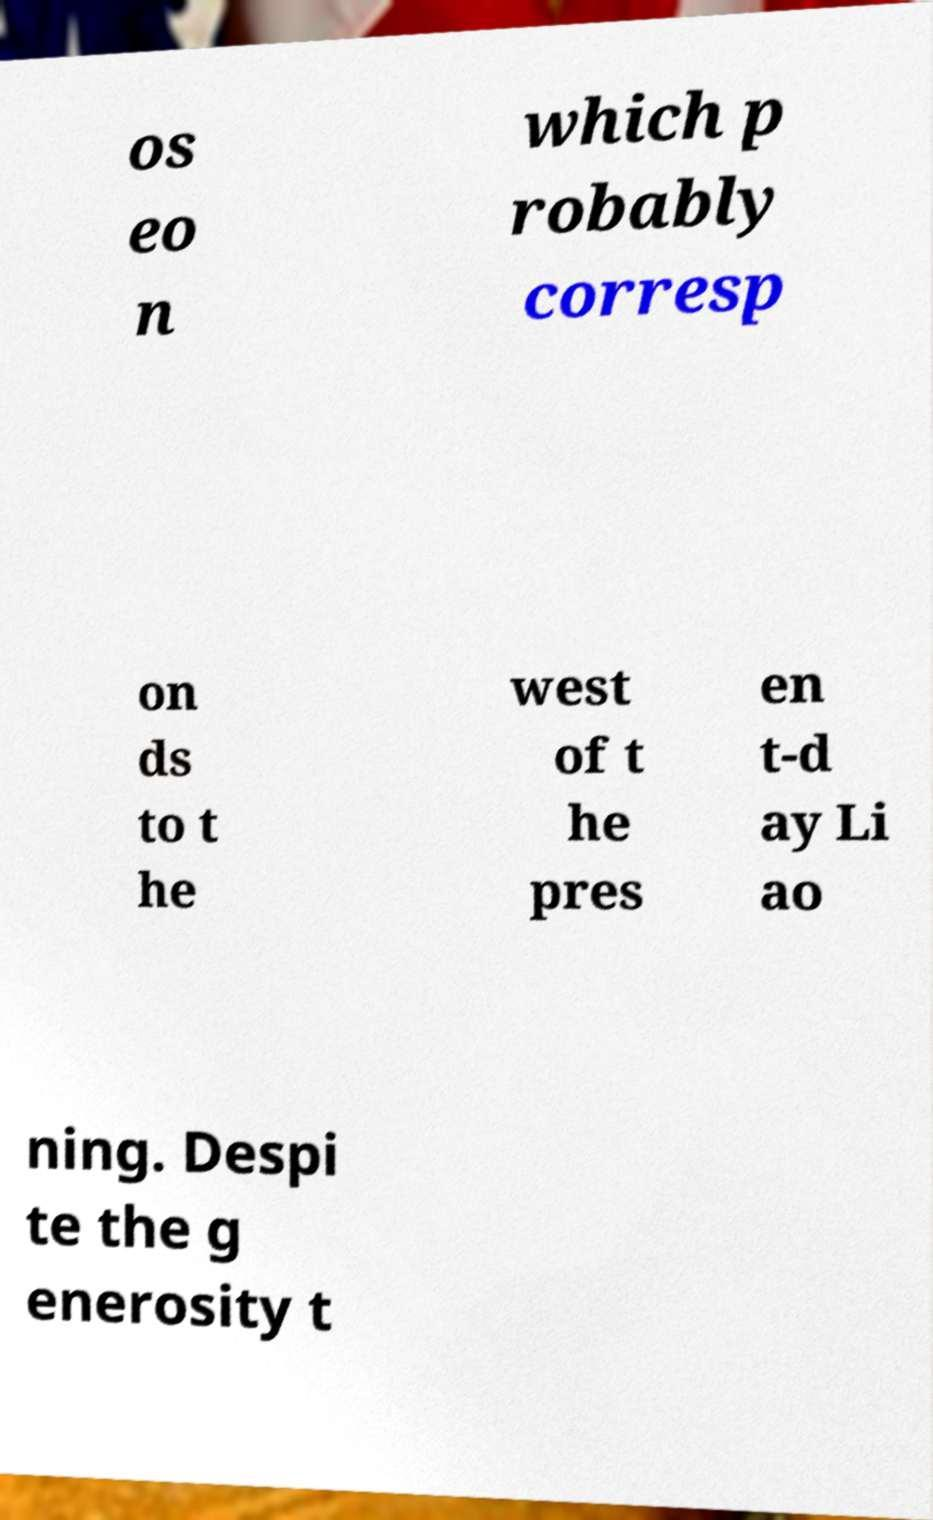Please read and relay the text visible in this image. What does it say? os eo n which p robably corresp on ds to t he west of t he pres en t-d ay Li ao ning. Despi te the g enerosity t 